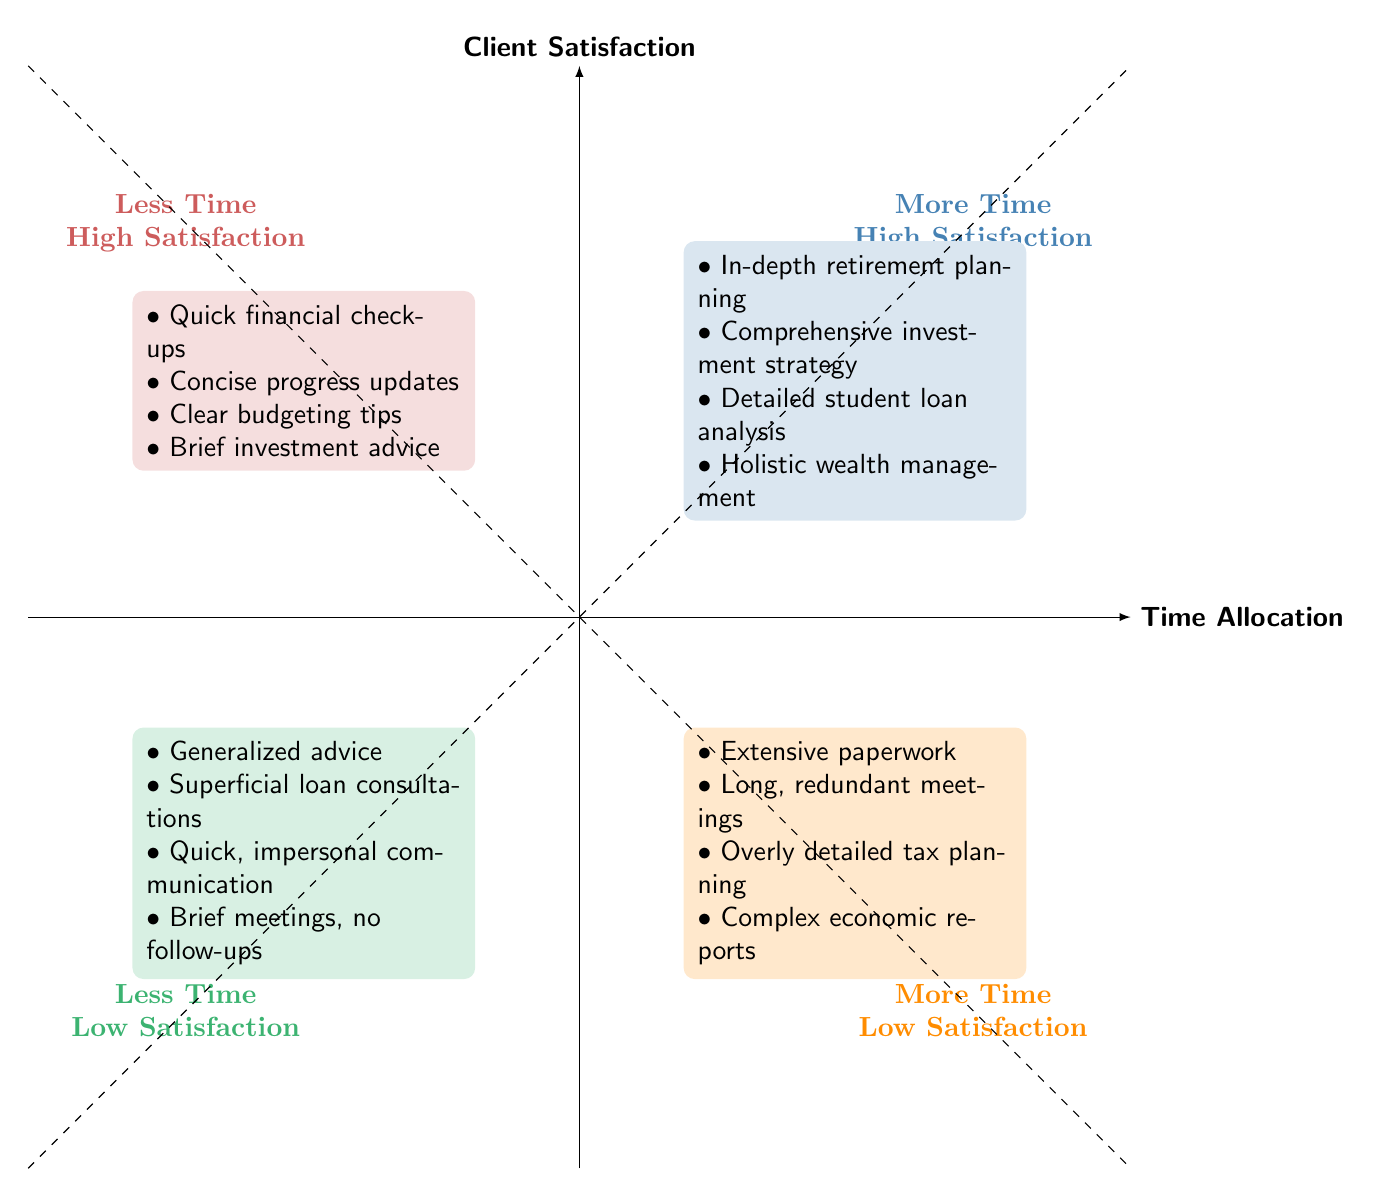What activities fall under 'More Time High Satisfaction'? The quadrant labeled "More Time High Satisfaction" lists the activities specifically associated with high client satisfaction when more time is allocated. These activities include in-depth retirement planning, comprehensive investment strategy development, detailed student loan repayment analysis, and holistic wealth management education.
Answer: In-depth retirement planning, comprehensive investment strategy development, detailed student loan repayment analysis, holistic wealth management education How many categories are labeled in the diagram? The diagram has four distinct categories presented in the quadrants, corresponding to different combinations of time allocation and client satisfaction: More Time High Satisfaction, Less Time High Satisfaction, More Time Low Satisfaction, and Less Time Low Satisfaction.
Answer: Four Which quadrant contains 'Extensive paperwork and documentation'? The activity 'Extensive paperwork and documentation' is listed in the quadrant called "More Time Low Satisfaction," which indicates that spending much time on this activity does not lead to high client satisfaction.
Answer: More Time Low Satisfaction What quadrant contains more general advice and why might that lead to low satisfaction? The quadrant labeled "Less Time Low Satisfaction" includes generalized advice, which lacks personalization and may not effectively address the unique needs of individual clients, resulting in lower satisfaction.
Answer: Less Time Low Satisfaction What are two activities found in the 'Less Time High Satisfaction' quadrant? This quadrant lists activities that, when allocated less time, still lead to high client satisfaction. Two specific activities found here are quick financial check-ups and concise progress updates.
Answer: Quick financial check-ups, concise progress updates What conclusion can be drawn about the relationship between more time and client satisfaction? The diagram suggests that activities requiring more time do not equally correspond to high client satisfaction; while some activities under 'More Time High Satisfaction' are positively viewed, a significant number of activities in 'More Time Low Satisfaction' reflect the opposite. Consequently, the relationship indicates that time invested does not guarantee satisfaction.
Answer: Time invested does not guarantee satisfaction 